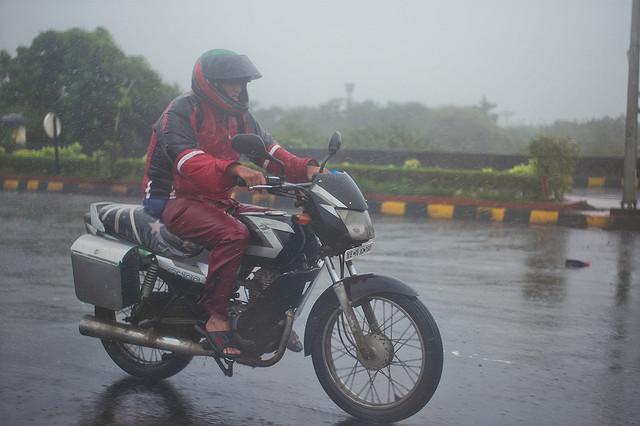Is this a vintage motorbike?
Answer briefly. No. Is the weather sunny?
Answer briefly. No. Is the exhaust pipe on this motorcycle new?
Quick response, please. No. Is there a paved street or a dirt trail in this photo?
Quick response, please. Paved. Is the rider wearing proper footwear for this activity?
Short answer required. No. 